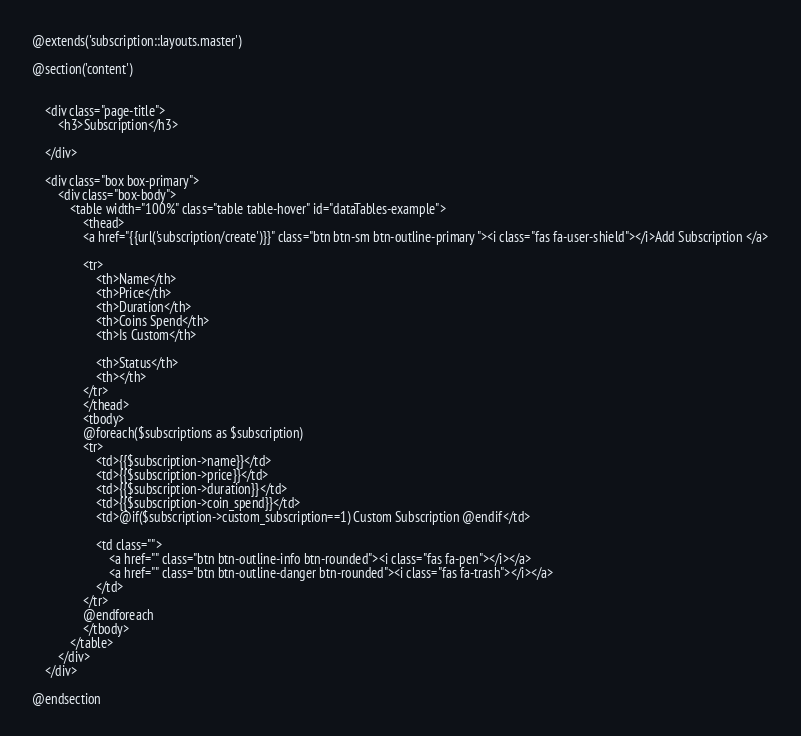<code> <loc_0><loc_0><loc_500><loc_500><_PHP_>@extends('subscription::layouts.master')

@section('content')


    <div class="page-title">
        <h3>Subscription</h3>

    </div>

    <div class="box box-primary">
        <div class="box-body">
            <table width="100%" class="table table-hover" id="dataTables-example">
                <thead>
                <a href="{{url('subscription/create')}}" class="btn btn-sm btn-outline-primary "><i class="fas fa-user-shield"></i>Add Subscription </a>

                <tr>
                    <th>Name</th>
                    <th>Price</th>
                    <th>Duration</th>
                    <th>Coins Spend</th>
                    <th>Is Custom</th>

                    <th>Status</th>
                    <th></th>
                </tr>
                </thead>
                <tbody>
                @foreach($subscriptions as $subscription)
                <tr>
                    <td>{{$subscription->name}}</td>
                    <td>{{$subscription->price}}</td>
                    <td>{{$subscription->duration}}</td>
                    <td>{{$subscription->coin_spend}}</td>
                    <td>@if($subscription->custom_subscription==1) Custom Subscription @endif</td>

                    <td class="">
                        <a href="" class="btn btn-outline-info btn-rounded"><i class="fas fa-pen"></i></a>
                        <a href="" class="btn btn-outline-danger btn-rounded"><i class="fas fa-trash"></i></a>
                    </td>
                </tr>
                @endforeach
                </tbody>
            </table>
        </div>
    </div>

@endsection
</code> 